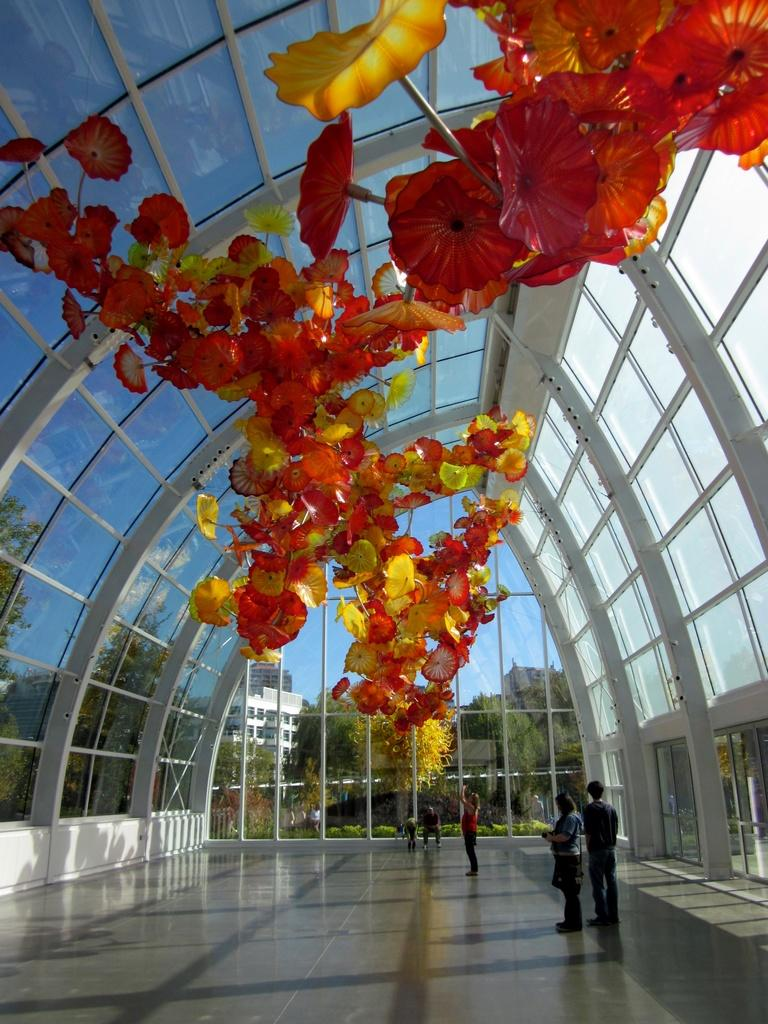What type of vegetation can be seen in the image? There are flowers and trees in the image. Are there any human subjects in the image? Yes, there are persons in the image. What architectural features are present in the image? There are glass windows, doors, and buildings in the image. What is visible in the background of the image? The sky is visible in the image. What type of question is being asked in the image? There is no question being asked in the image; it features flowers, trees, persons, glass windows, doors, buildings, and the sky. Is there a plantation visible in the image? There is no plantation present in the image. 